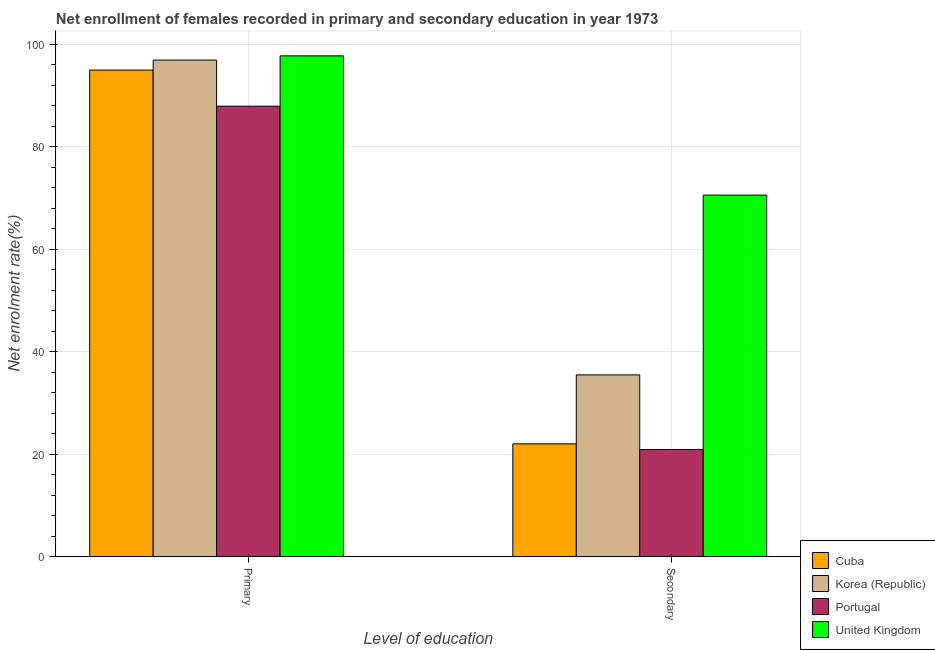How many different coloured bars are there?
Offer a very short reply. 4. Are the number of bars per tick equal to the number of legend labels?
Ensure brevity in your answer.  Yes. Are the number of bars on each tick of the X-axis equal?
Your answer should be very brief. Yes. How many bars are there on the 2nd tick from the left?
Your answer should be very brief. 4. What is the label of the 1st group of bars from the left?
Your answer should be compact. Primary. What is the enrollment rate in secondary education in Korea (Republic)?
Provide a succinct answer. 35.47. Across all countries, what is the maximum enrollment rate in secondary education?
Offer a very short reply. 70.58. Across all countries, what is the minimum enrollment rate in secondary education?
Your answer should be very brief. 20.9. In which country was the enrollment rate in secondary education maximum?
Your answer should be compact. United Kingdom. What is the total enrollment rate in secondary education in the graph?
Your answer should be compact. 148.95. What is the difference between the enrollment rate in primary education in Cuba and that in Portugal?
Give a very brief answer. 7.06. What is the difference between the enrollment rate in primary education in Portugal and the enrollment rate in secondary education in Cuba?
Make the answer very short. 65.95. What is the average enrollment rate in secondary education per country?
Keep it short and to the point. 37.24. What is the difference between the enrollment rate in secondary education and enrollment rate in primary education in Cuba?
Your answer should be very brief. -73. What is the ratio of the enrollment rate in primary education in Korea (Republic) to that in United Kingdom?
Make the answer very short. 0.99. In how many countries, is the enrollment rate in secondary education greater than the average enrollment rate in secondary education taken over all countries?
Provide a succinct answer. 1. What does the 1st bar from the left in Primary represents?
Ensure brevity in your answer.  Cuba. What does the 3rd bar from the right in Primary represents?
Offer a terse response. Korea (Republic). How many bars are there?
Make the answer very short. 8. Are all the bars in the graph horizontal?
Your answer should be very brief. No. How many countries are there in the graph?
Ensure brevity in your answer.  4. Does the graph contain any zero values?
Give a very brief answer. No. Does the graph contain grids?
Make the answer very short. Yes. Where does the legend appear in the graph?
Provide a short and direct response. Bottom right. What is the title of the graph?
Your answer should be compact. Net enrollment of females recorded in primary and secondary education in year 1973. Does "Lesotho" appear as one of the legend labels in the graph?
Make the answer very short. No. What is the label or title of the X-axis?
Provide a succinct answer. Level of education. What is the label or title of the Y-axis?
Make the answer very short. Net enrolment rate(%). What is the Net enrolment rate(%) of Cuba in Primary?
Offer a terse response. 95. What is the Net enrolment rate(%) of Korea (Republic) in Primary?
Give a very brief answer. 96.95. What is the Net enrolment rate(%) of Portugal in Primary?
Give a very brief answer. 87.94. What is the Net enrolment rate(%) in United Kingdom in Primary?
Offer a very short reply. 97.77. What is the Net enrolment rate(%) in Cuba in Secondary?
Keep it short and to the point. 22. What is the Net enrolment rate(%) in Korea (Republic) in Secondary?
Your response must be concise. 35.47. What is the Net enrolment rate(%) of Portugal in Secondary?
Your answer should be very brief. 20.9. What is the Net enrolment rate(%) in United Kingdom in Secondary?
Offer a very short reply. 70.58. Across all Level of education, what is the maximum Net enrolment rate(%) of Cuba?
Provide a short and direct response. 95. Across all Level of education, what is the maximum Net enrolment rate(%) of Korea (Republic)?
Provide a succinct answer. 96.95. Across all Level of education, what is the maximum Net enrolment rate(%) of Portugal?
Keep it short and to the point. 87.94. Across all Level of education, what is the maximum Net enrolment rate(%) of United Kingdom?
Provide a succinct answer. 97.77. Across all Level of education, what is the minimum Net enrolment rate(%) in Cuba?
Provide a succinct answer. 22. Across all Level of education, what is the minimum Net enrolment rate(%) of Korea (Republic)?
Provide a succinct answer. 35.47. Across all Level of education, what is the minimum Net enrolment rate(%) of Portugal?
Make the answer very short. 20.9. Across all Level of education, what is the minimum Net enrolment rate(%) in United Kingdom?
Offer a terse response. 70.58. What is the total Net enrolment rate(%) in Cuba in the graph?
Give a very brief answer. 117. What is the total Net enrolment rate(%) in Korea (Republic) in the graph?
Make the answer very short. 132.42. What is the total Net enrolment rate(%) of Portugal in the graph?
Provide a succinct answer. 108.84. What is the total Net enrolment rate(%) of United Kingdom in the graph?
Offer a very short reply. 168.35. What is the difference between the Net enrolment rate(%) of Cuba in Primary and that in Secondary?
Your answer should be compact. 73. What is the difference between the Net enrolment rate(%) in Korea (Republic) in Primary and that in Secondary?
Offer a terse response. 61.48. What is the difference between the Net enrolment rate(%) of Portugal in Primary and that in Secondary?
Ensure brevity in your answer.  67.05. What is the difference between the Net enrolment rate(%) of United Kingdom in Primary and that in Secondary?
Your response must be concise. 27.19. What is the difference between the Net enrolment rate(%) in Cuba in Primary and the Net enrolment rate(%) in Korea (Republic) in Secondary?
Keep it short and to the point. 59.53. What is the difference between the Net enrolment rate(%) in Cuba in Primary and the Net enrolment rate(%) in Portugal in Secondary?
Offer a terse response. 74.1. What is the difference between the Net enrolment rate(%) of Cuba in Primary and the Net enrolment rate(%) of United Kingdom in Secondary?
Your answer should be compact. 24.42. What is the difference between the Net enrolment rate(%) of Korea (Republic) in Primary and the Net enrolment rate(%) of Portugal in Secondary?
Keep it short and to the point. 76.05. What is the difference between the Net enrolment rate(%) of Korea (Republic) in Primary and the Net enrolment rate(%) of United Kingdom in Secondary?
Offer a very short reply. 26.37. What is the difference between the Net enrolment rate(%) in Portugal in Primary and the Net enrolment rate(%) in United Kingdom in Secondary?
Provide a succinct answer. 17.36. What is the average Net enrolment rate(%) of Cuba per Level of education?
Offer a very short reply. 58.5. What is the average Net enrolment rate(%) of Korea (Republic) per Level of education?
Offer a terse response. 66.21. What is the average Net enrolment rate(%) of Portugal per Level of education?
Provide a short and direct response. 54.42. What is the average Net enrolment rate(%) in United Kingdom per Level of education?
Your response must be concise. 84.18. What is the difference between the Net enrolment rate(%) of Cuba and Net enrolment rate(%) of Korea (Republic) in Primary?
Keep it short and to the point. -1.95. What is the difference between the Net enrolment rate(%) of Cuba and Net enrolment rate(%) of Portugal in Primary?
Provide a short and direct response. 7.06. What is the difference between the Net enrolment rate(%) of Cuba and Net enrolment rate(%) of United Kingdom in Primary?
Keep it short and to the point. -2.77. What is the difference between the Net enrolment rate(%) of Korea (Republic) and Net enrolment rate(%) of Portugal in Primary?
Ensure brevity in your answer.  9. What is the difference between the Net enrolment rate(%) of Korea (Republic) and Net enrolment rate(%) of United Kingdom in Primary?
Your answer should be compact. -0.82. What is the difference between the Net enrolment rate(%) of Portugal and Net enrolment rate(%) of United Kingdom in Primary?
Keep it short and to the point. -9.83. What is the difference between the Net enrolment rate(%) of Cuba and Net enrolment rate(%) of Korea (Republic) in Secondary?
Your answer should be very brief. -13.47. What is the difference between the Net enrolment rate(%) of Cuba and Net enrolment rate(%) of Portugal in Secondary?
Ensure brevity in your answer.  1.1. What is the difference between the Net enrolment rate(%) of Cuba and Net enrolment rate(%) of United Kingdom in Secondary?
Keep it short and to the point. -48.58. What is the difference between the Net enrolment rate(%) in Korea (Republic) and Net enrolment rate(%) in Portugal in Secondary?
Your answer should be compact. 14.57. What is the difference between the Net enrolment rate(%) of Korea (Republic) and Net enrolment rate(%) of United Kingdom in Secondary?
Provide a short and direct response. -35.11. What is the difference between the Net enrolment rate(%) of Portugal and Net enrolment rate(%) of United Kingdom in Secondary?
Offer a terse response. -49.68. What is the ratio of the Net enrolment rate(%) of Cuba in Primary to that in Secondary?
Give a very brief answer. 4.32. What is the ratio of the Net enrolment rate(%) of Korea (Republic) in Primary to that in Secondary?
Make the answer very short. 2.73. What is the ratio of the Net enrolment rate(%) in Portugal in Primary to that in Secondary?
Your answer should be compact. 4.21. What is the ratio of the Net enrolment rate(%) of United Kingdom in Primary to that in Secondary?
Make the answer very short. 1.39. What is the difference between the highest and the second highest Net enrolment rate(%) in Cuba?
Your answer should be compact. 73. What is the difference between the highest and the second highest Net enrolment rate(%) of Korea (Republic)?
Your answer should be compact. 61.48. What is the difference between the highest and the second highest Net enrolment rate(%) of Portugal?
Keep it short and to the point. 67.05. What is the difference between the highest and the second highest Net enrolment rate(%) in United Kingdom?
Offer a terse response. 27.19. What is the difference between the highest and the lowest Net enrolment rate(%) of Cuba?
Your answer should be very brief. 73. What is the difference between the highest and the lowest Net enrolment rate(%) of Korea (Republic)?
Provide a succinct answer. 61.48. What is the difference between the highest and the lowest Net enrolment rate(%) of Portugal?
Offer a very short reply. 67.05. What is the difference between the highest and the lowest Net enrolment rate(%) in United Kingdom?
Your response must be concise. 27.19. 